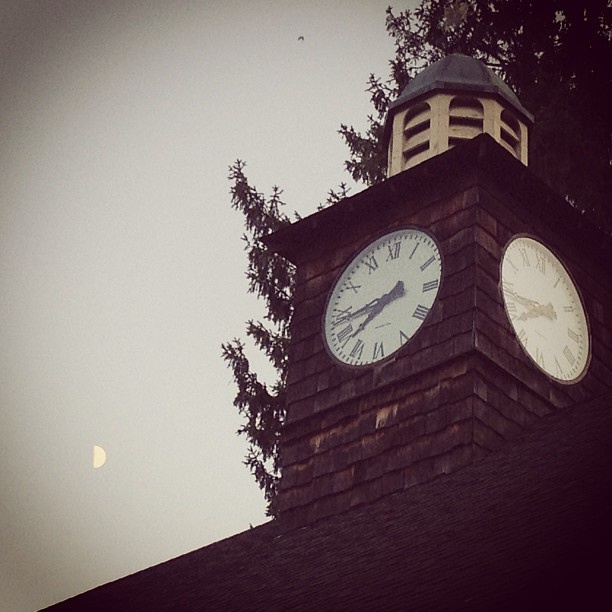Describe the objects in this image and their specific colors. I can see clock in gray, darkgray, and black tones, clock in gray, darkgray, lightgray, and black tones, bird in gray and darkgray tones, and bird in gray, darkgray, and black tones in this image. 